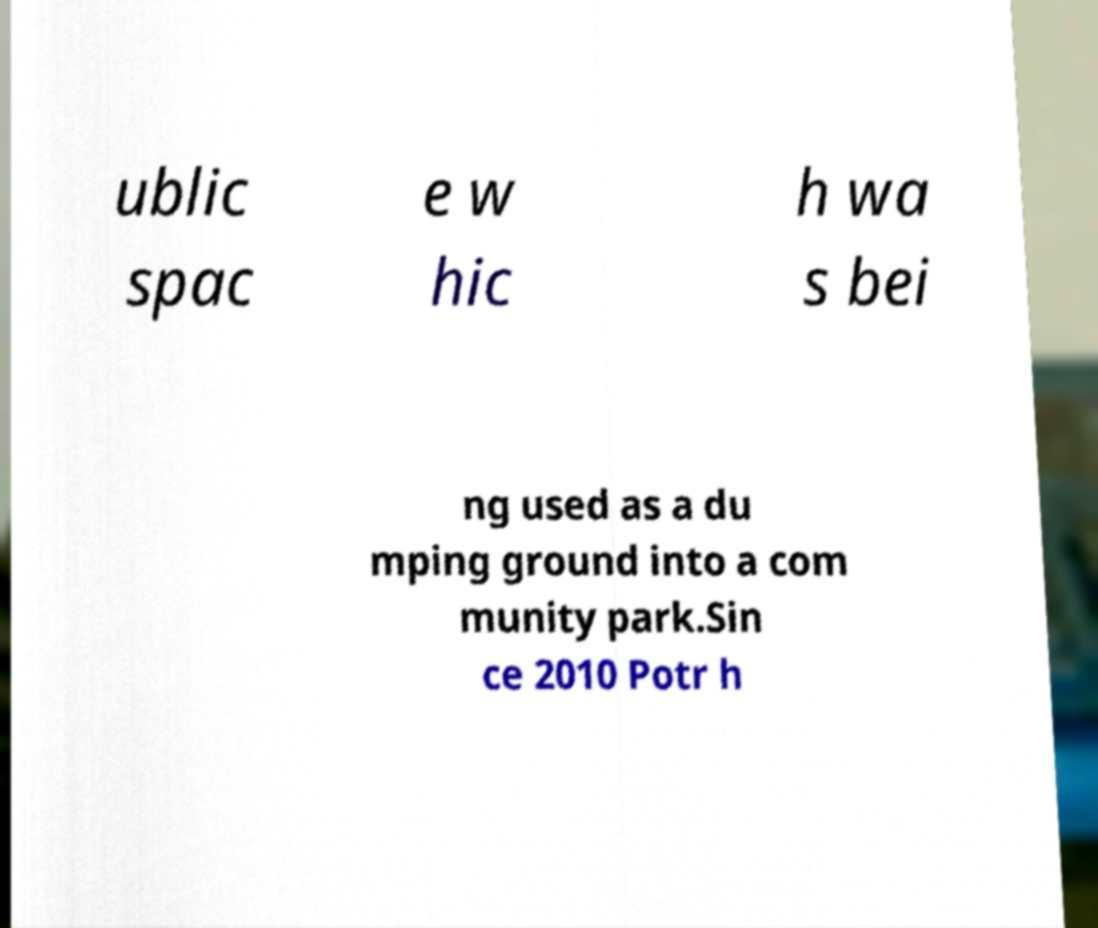Please read and relay the text visible in this image. What does it say? ublic spac e w hic h wa s bei ng used as a du mping ground into a com munity park.Sin ce 2010 Potr h 